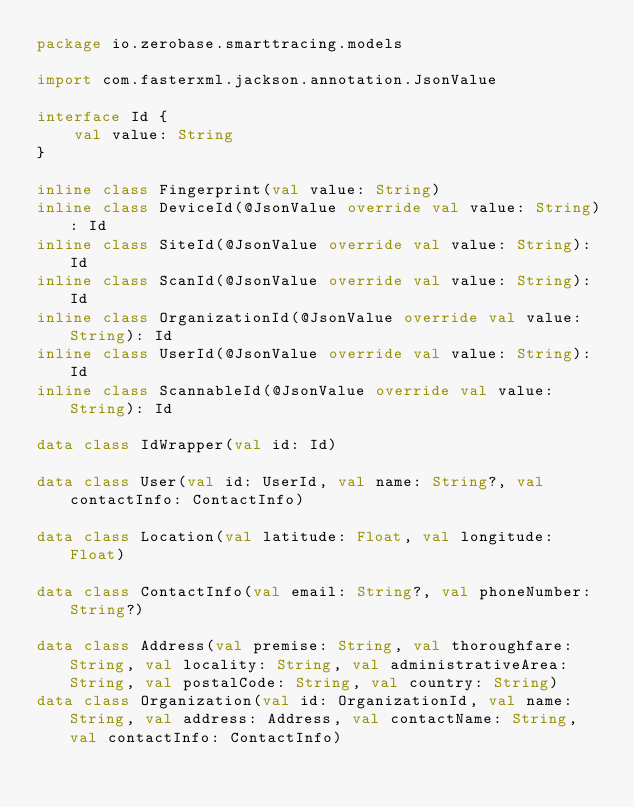<code> <loc_0><loc_0><loc_500><loc_500><_Kotlin_>package io.zerobase.smarttracing.models

import com.fasterxml.jackson.annotation.JsonValue

interface Id {
    val value: String
}

inline class Fingerprint(val value: String)
inline class DeviceId(@JsonValue override val value: String): Id
inline class SiteId(@JsonValue override val value: String): Id
inline class ScanId(@JsonValue override val value: String): Id
inline class OrganizationId(@JsonValue override val value: String): Id
inline class UserId(@JsonValue override val value: String): Id
inline class ScannableId(@JsonValue override val value: String): Id

data class IdWrapper(val id: Id)

data class User(val id: UserId, val name: String?, val contactInfo: ContactInfo)

data class Location(val latitude: Float, val longitude: Float)

data class ContactInfo(val email: String?, val phoneNumber: String?)

data class Address(val premise: String, val thoroughfare: String, val locality: String, val administrativeArea: String, val postalCode: String, val country: String)
data class Organization(val id: OrganizationId, val name: String, val address: Address, val contactName: String, val contactInfo: ContactInfo)
</code> 